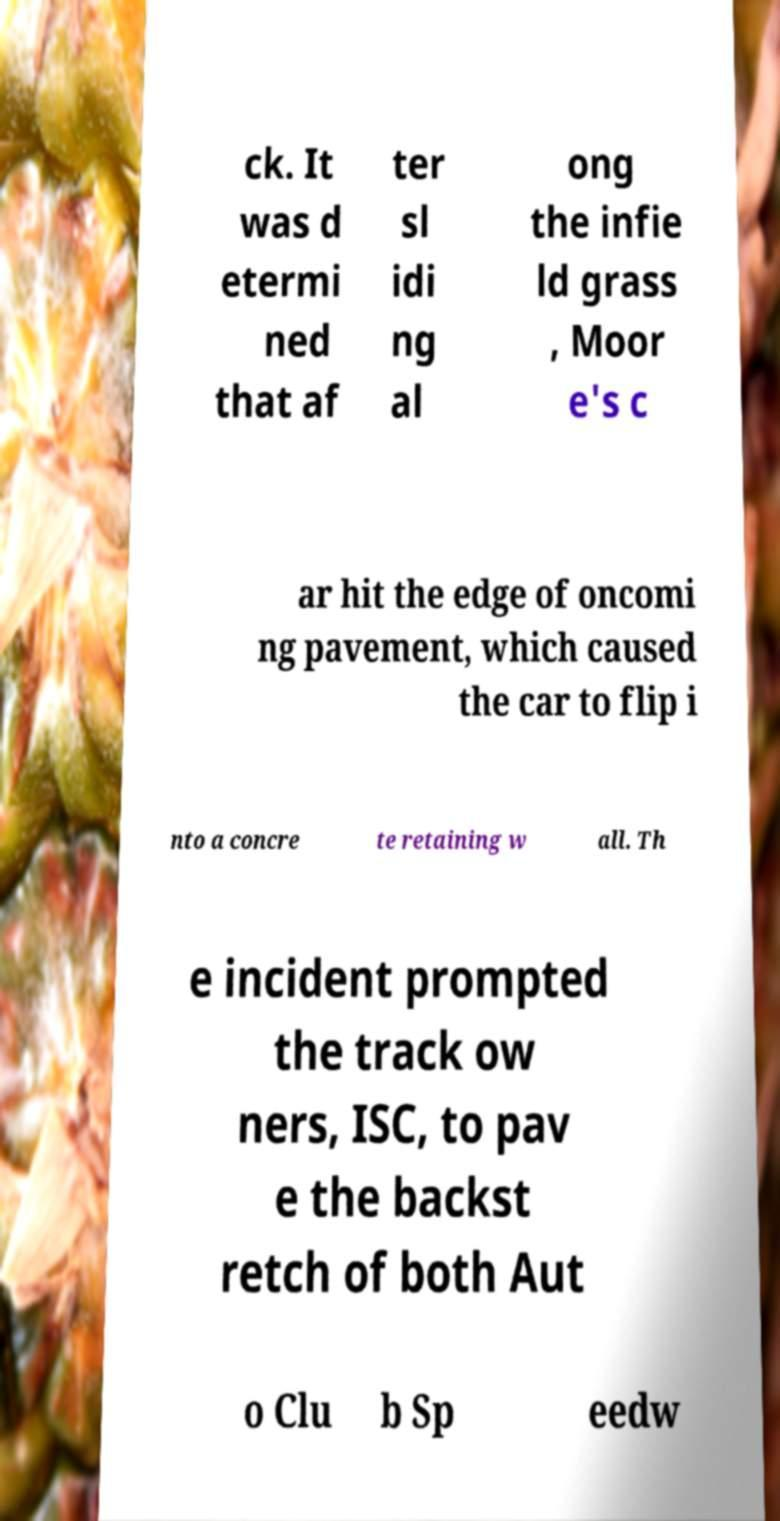I need the written content from this picture converted into text. Can you do that? ck. It was d etermi ned that af ter sl idi ng al ong the infie ld grass , Moor e's c ar hit the edge of oncomi ng pavement, which caused the car to flip i nto a concre te retaining w all. Th e incident prompted the track ow ners, ISC, to pav e the backst retch of both Aut o Clu b Sp eedw 